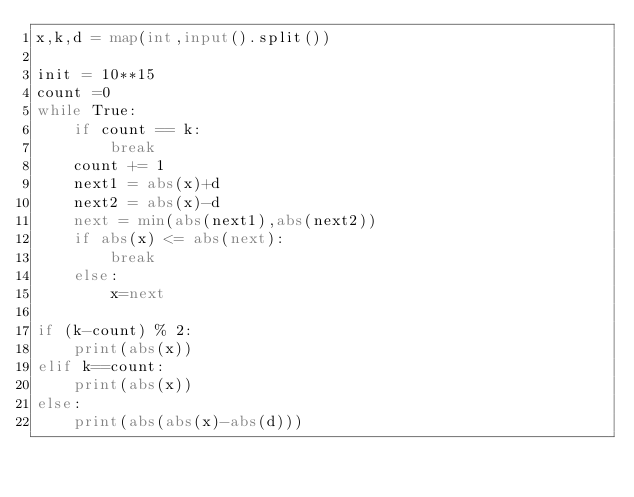Convert code to text. <code><loc_0><loc_0><loc_500><loc_500><_Python_>x,k,d = map(int,input().split())

init = 10**15
count =0
while True:
    if count == k:
        break
    count += 1
    next1 = abs(x)+d
    next2 = abs(x)-d
    next = min(abs(next1),abs(next2))
    if abs(x) <= abs(next):
        break
    else:
        x=next

if (k-count) % 2:
    print(abs(x))
elif k==count:
    print(abs(x))
else:
    print(abs(abs(x)-abs(d)))</code> 